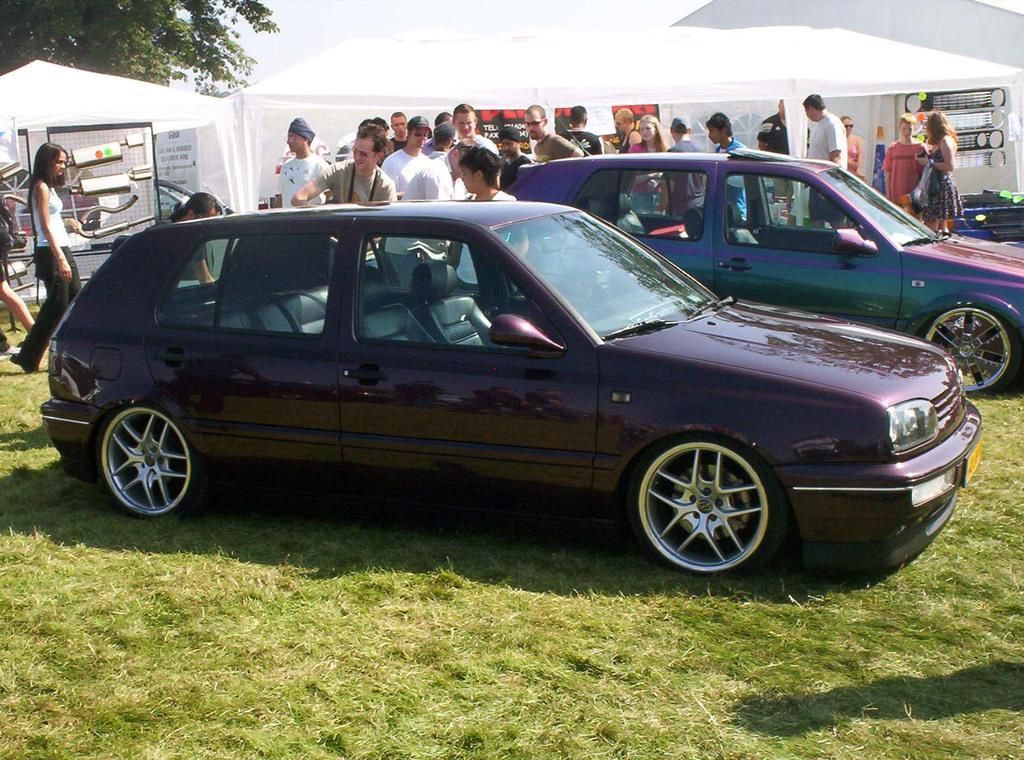Can you describe this image briefly? In this image there are cars parked on the ground. There is grass on the ground. Behind the cars there are many people standing. Behind them there are tents. In the top left there is a tree. 